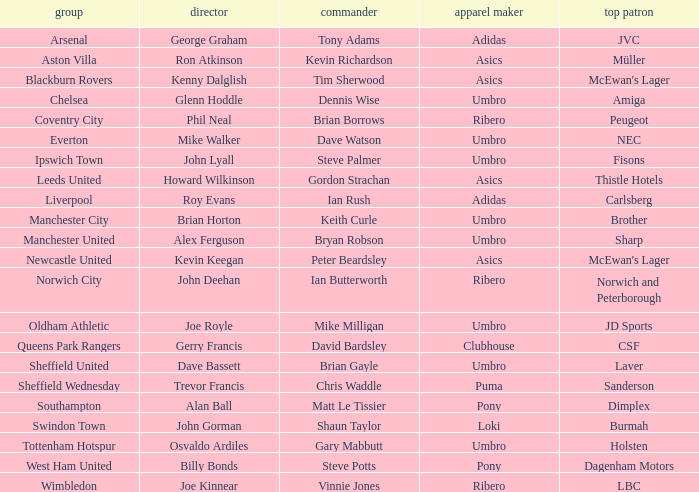Which team has george graham as the manager? Arsenal. 